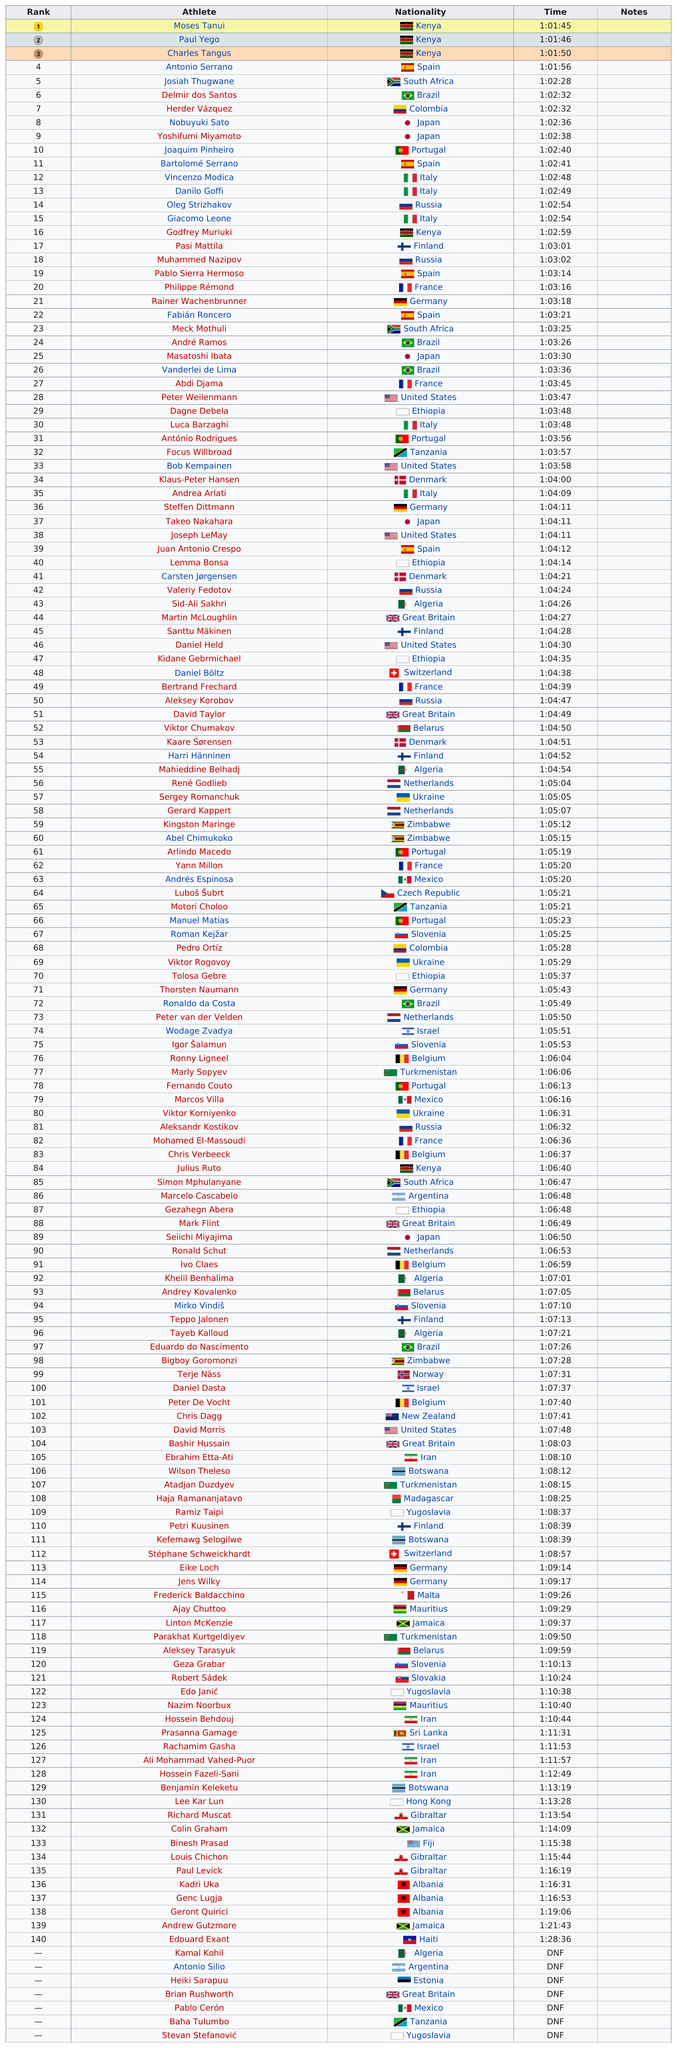Draw attention to some important aspects in this diagram. Peter Weilenmann, an American, achieved the fastest time among all Americans in the competition. The first three winners placed within 1 hour and 50 seconds. Charles Tangus, an athlete from Kenya, participated in the event but placed third. The time it took for Meck Mothuli to finish the race was 1 hour and 3 minutes and 25 seconds. Moses Tanui was the only participant who won first place. 